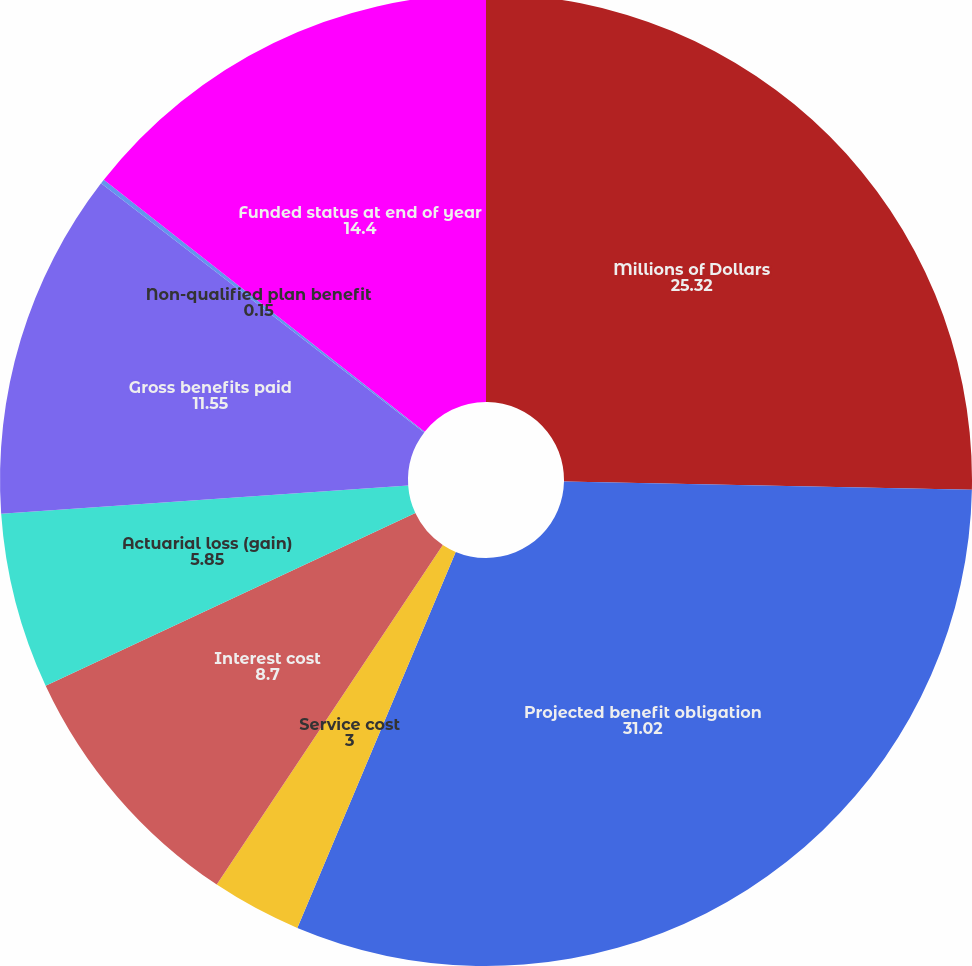Convert chart. <chart><loc_0><loc_0><loc_500><loc_500><pie_chart><fcel>Millions of Dollars<fcel>Projected benefit obligation<fcel>Service cost<fcel>Interest cost<fcel>Actuarial loss (gain)<fcel>Gross benefits paid<fcel>Non-qualified plan benefit<fcel>Funded status at end of year<nl><fcel>25.32%<fcel>31.02%<fcel>3.0%<fcel>8.7%<fcel>5.85%<fcel>11.55%<fcel>0.15%<fcel>14.4%<nl></chart> 